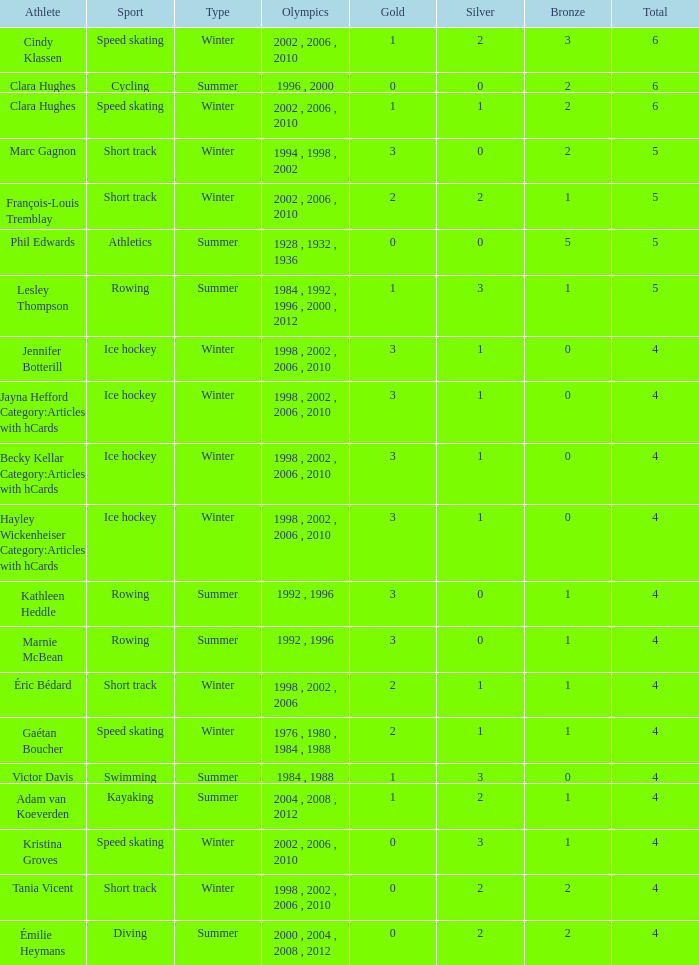What is the greatest sum of medals winter athlete clara hughes has earned? 6.0. Can you parse all the data within this table? {'header': ['Athlete', 'Sport', 'Type', 'Olympics', 'Gold', 'Silver', 'Bronze', 'Total'], 'rows': [['Cindy Klassen', 'Speed skating', 'Winter', '2002 , 2006 , 2010', '1', '2', '3', '6'], ['Clara Hughes', 'Cycling', 'Summer', '1996 , 2000', '0', '0', '2', '6'], ['Clara Hughes', 'Speed skating', 'Winter', '2002 , 2006 , 2010', '1', '1', '2', '6'], ['Marc Gagnon', 'Short track', 'Winter', '1994 , 1998 , 2002', '3', '0', '2', '5'], ['François-Louis Tremblay', 'Short track', 'Winter', '2002 , 2006 , 2010', '2', '2', '1', '5'], ['Phil Edwards', 'Athletics', 'Summer', '1928 , 1932 , 1936', '0', '0', '5', '5'], ['Lesley Thompson', 'Rowing', 'Summer', '1984 , 1992 , 1996 , 2000 , 2012', '1', '3', '1', '5'], ['Jennifer Botterill', 'Ice hockey', 'Winter', '1998 , 2002 , 2006 , 2010', '3', '1', '0', '4'], ['Jayna Hefford Category:Articles with hCards', 'Ice hockey', 'Winter', '1998 , 2002 , 2006 , 2010', '3', '1', '0', '4'], ['Becky Kellar Category:Articles with hCards', 'Ice hockey', 'Winter', '1998 , 2002 , 2006 , 2010', '3', '1', '0', '4'], ['Hayley Wickenheiser Category:Articles with hCards', 'Ice hockey', 'Winter', '1998 , 2002 , 2006 , 2010', '3', '1', '0', '4'], ['Kathleen Heddle', 'Rowing', 'Summer', '1992 , 1996', '3', '0', '1', '4'], ['Marnie McBean', 'Rowing', 'Summer', '1992 , 1996', '3', '0', '1', '4'], ['Éric Bédard', 'Short track', 'Winter', '1998 , 2002 , 2006', '2', '1', '1', '4'], ['Gaétan Boucher', 'Speed skating', 'Winter', '1976 , 1980 , 1984 , 1988', '2', '1', '1', '4'], ['Victor Davis', 'Swimming', 'Summer', '1984 , 1988', '1', '3', '0', '4'], ['Adam van Koeverden', 'Kayaking', 'Summer', '2004 , 2008 , 2012', '1', '2', '1', '4'], ['Kristina Groves', 'Speed skating', 'Winter', '2002 , 2006 , 2010', '0', '3', '1', '4'], ['Tania Vicent', 'Short track', 'Winter', '1998 , 2002 , 2006 , 2010', '0', '2', '2', '4'], ['Émilie Heymans', 'Diving', 'Summer', '2000 , 2004 , 2008 , 2012', '0', '2', '2', '4']]} 